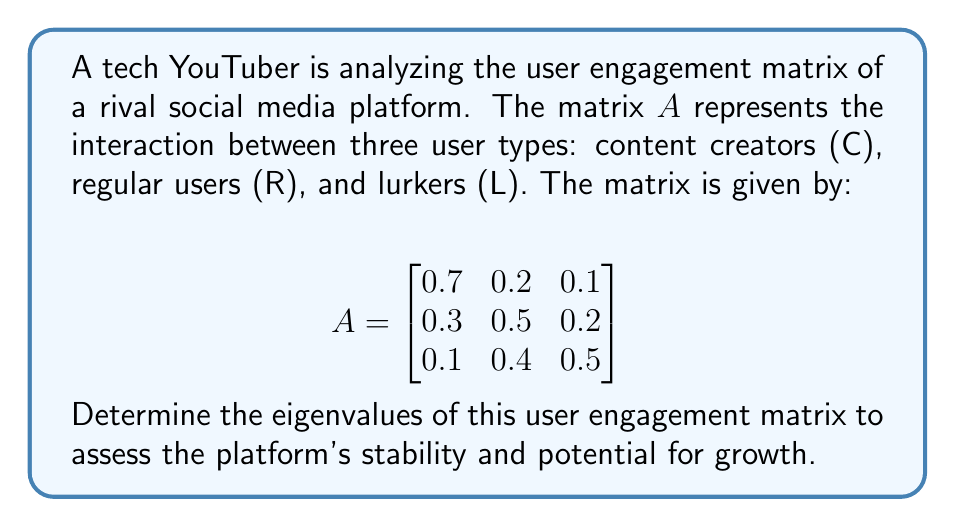Can you answer this question? To find the eigenvalues of matrix $A$, we need to solve the characteristic equation:

$\det(A - \lambda I) = 0$

where $I$ is the 3x3 identity matrix and $\lambda$ represents the eigenvalues.

Step 1: Set up the characteristic equation:
$$\det\begin{pmatrix}
0.7-\lambda & 0.2 & 0.1 \\
0.3 & 0.5-\lambda & 0.2 \\
0.1 & 0.4 & 0.5-\lambda
\end{pmatrix} = 0$$

Step 2: Expand the determinant:
$$(0.7-\lambda)[(0.5-\lambda)(0.5-\lambda) - 0.08] - 0.2[0.3(0.5-\lambda) - 0.02] + 0.1[0.12 - 0.3(0.4)] = 0$$

Step 3: Simplify:
$$(0.7-\lambda)[(0.25-0.5\lambda+\lambda^2) - 0.08] - 0.2[0.15-0.3\lambda - 0.02] + 0.1[0.12 - 0.12] = 0$$
$$(0.7-\lambda)(0.17-0.5\lambda+\lambda^2) - 0.2(0.13-0.3\lambda) = 0$$

Step 4: Expand and collect terms:
$$0.119 - 0.35\lambda + 0.7\lambda^2 - 0.17\lambda + 0.5\lambda^2 - \lambda^3 - 0.026 + 0.06\lambda = 0$$
$$-\lambda^3 + 1.2\lambda^2 - 0.46\lambda + 0.093 = 0$$

Step 5: Solve the cubic equation. This can be done using the cubic formula or numerical methods. The solutions are approximately:

$\lambda_1 \approx 1$
$\lambda_2 \approx 0.1$
$\lambda_3 \approx 0.1$

These eigenvalues represent the principal components of user engagement on the platform. The largest eigenvalue (1) indicates the dominant mode of interaction, while the two smaller, equal eigenvalues (0.1) suggest secondary, less influential modes of engagement.
Answer: $\lambda_1 \approx 1$, $\lambda_2 \approx 0.1$, $\lambda_3 \approx 0.1$ 